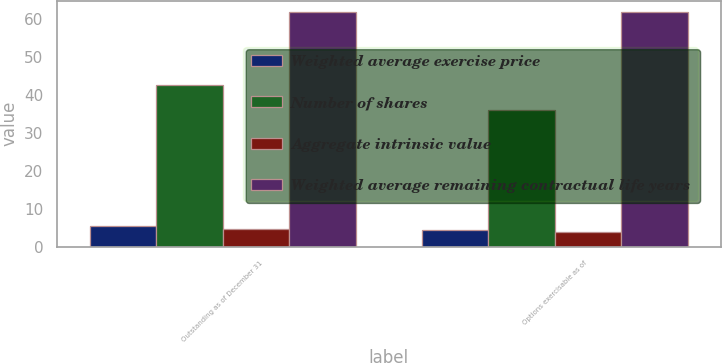<chart> <loc_0><loc_0><loc_500><loc_500><stacked_bar_chart><ecel><fcel>Outstanding as of December 31<fcel>Options exercisable as of<nl><fcel>Weighted average exercise price<fcel>5.6<fcel>4.4<nl><fcel>Number of shares<fcel>42.55<fcel>35.93<nl><fcel>Aggregate intrinsic value<fcel>4.8<fcel>3.9<nl><fcel>Weighted average remaining contractual life years<fcel>61.7<fcel>61.7<nl></chart> 